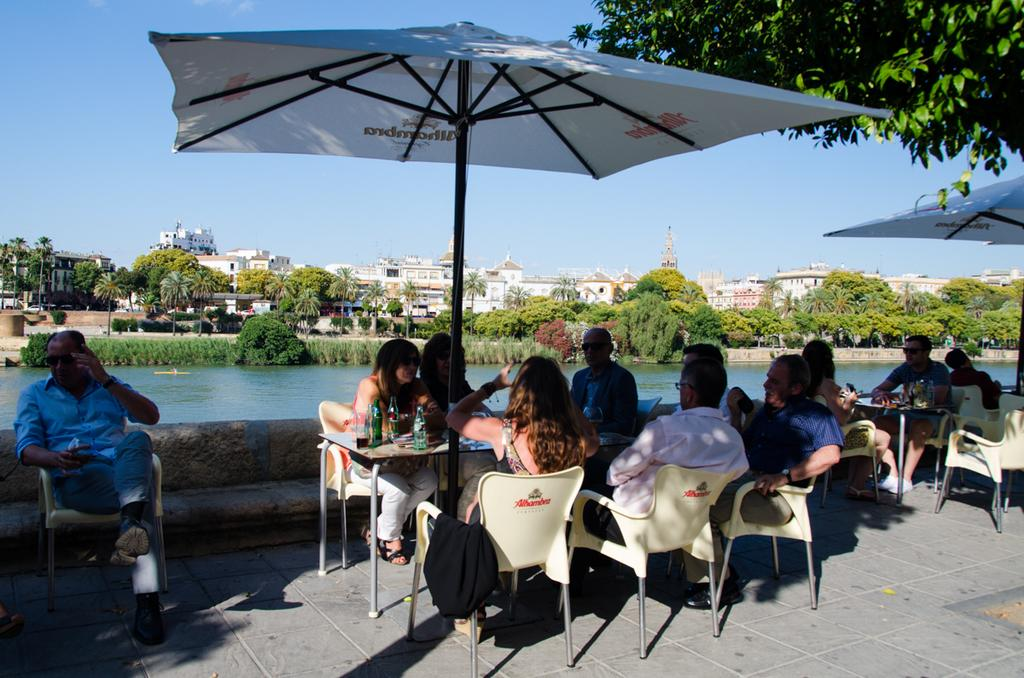Where is the setting of the image? The image is set outside of a city. What are the people in the image doing? There are people sitting in a chair in the image. What object is present to provide shade or shelter from the elements? There is an umbrella in the image. What can be seen in the distance behind the people? There are buildings visible in the background, as well as a tree and the sky. How many babies are crawling on the ground in the image? There are no babies present in the image; it features people sitting in a chair with an umbrella in the background. What type of paste is being used to stick the heart to the tree in the image? There is no heart or paste present in the image; it only shows people sitting in a chair, an umbrella, and the background. 